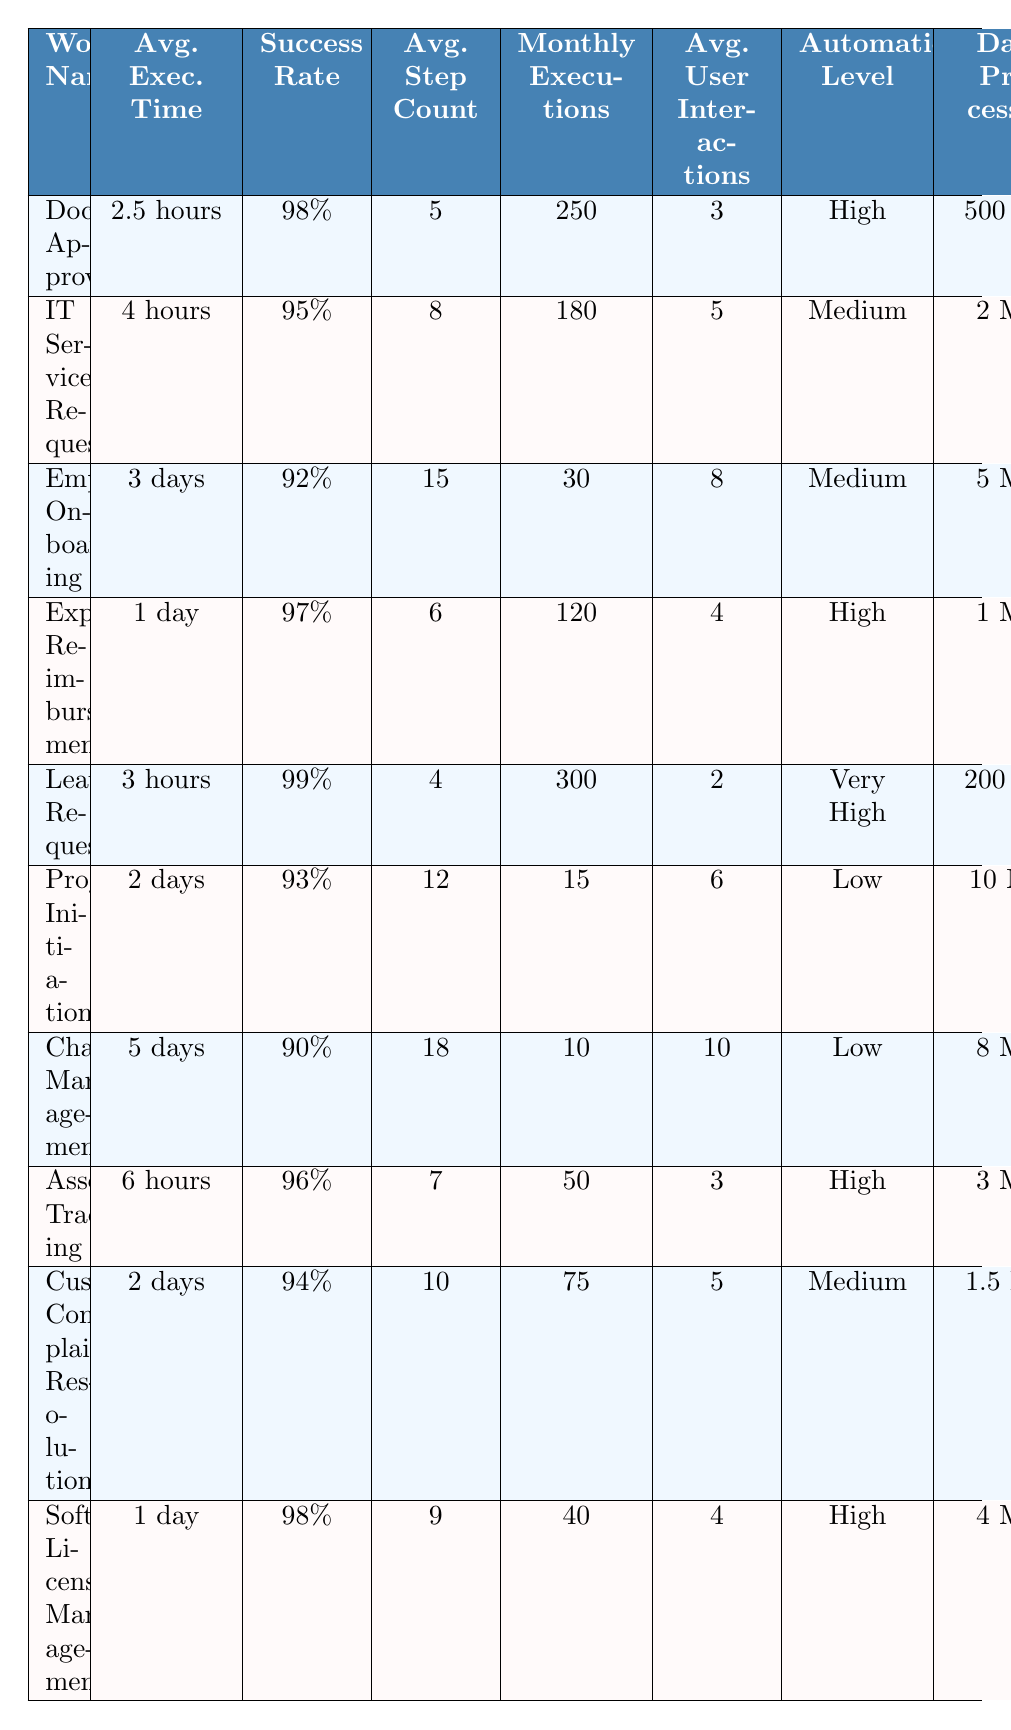What is the average execution time for the "Leave Request" workflow? The table lists the average execution time for the "Leave Request" workflow, which is directly stated as "3 hours."
Answer: 3 hours Which workflow has the highest success rate? By examining the success rates of all workflows listed in the table, we see that the "Leave Request" workflow has the highest success rate at 99%.
Answer: Leave Request How many workflows have an average execution time of more than 2 days? The workflows with execution times over 2 days are "Employee Onboarding" (3 days), "Project Initiation" (2 days), and "Change Management" (5 days). This totals 3 workflows.
Answer: 3 What is the total monthly execution count for all workflows? Summing the monthly executions from the table gives: 250 + 180 + 30 + 120 + 300 + 15 + 10 + 50 + 75 + 40 = 1,100.
Answer: 1,100 Does "Expense Reimbursement" have a higher success rate than "Customer Complaint Resolution"? Checking the success rates, "Expense Reimbursement" has a success rate of 97%, while "Customer Complaint Resolution" has a rate of 94%. Thus, "Expense Reimbursement" does indeed have a higher success rate.
Answer: Yes Which workflow has the lowest average user interactions? By reviewing the table, the workflow with the lowest average user interactions is "Leave Request," with an average of 2 interactions.
Answer: Leave Request Calculate the average step count for workflows that are classified as "Low" automation level. The workflows classified as "Low" are "Project Initiation" (12 steps) and "Change Management" (18 steps). The average is (12 + 18) / 2 = 15 steps.
Answer: 15 How many integrated systems are utilized by the "Software License Management" workflow? The "Software License Management" workflow integrates with "SCCM" and "Active Directory." Therefore, it utilizes 2 integrated systems.
Answer: 2 Is the average execution time for the "IT Service Request" greater than 3 hours? The average execution time for "IT Service Request" is listed as 4 hours, which is greater than 3 hours.
Answer: Yes Identify the workflow with the highest average data processed per execution. Analyzing the data processed per execution, the "Project Initiation" workflow processes the highest amount at 10 MB per execution.
Answer: Project Initiation 